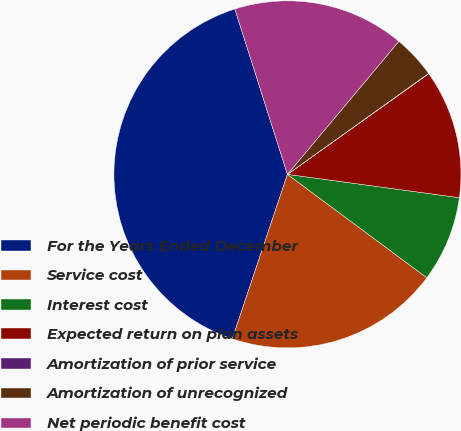<chart> <loc_0><loc_0><loc_500><loc_500><pie_chart><fcel>For the Years Ended December<fcel>Service cost<fcel>Interest cost<fcel>Expected return on plan assets<fcel>Amortization of prior service<fcel>Amortization of unrecognized<fcel>Net periodic benefit cost<nl><fcel>39.95%<fcel>19.99%<fcel>8.01%<fcel>12.0%<fcel>0.03%<fcel>4.02%<fcel>16.0%<nl></chart> 